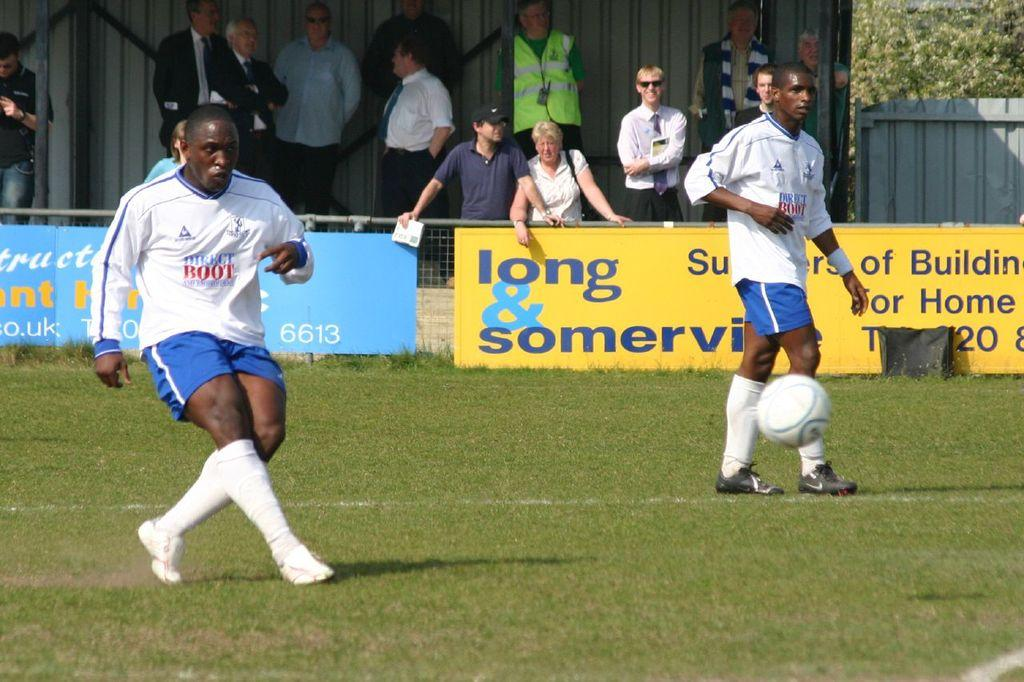<image>
Write a terse but informative summary of the picture. Soccer players with jerseys that say direct boot 